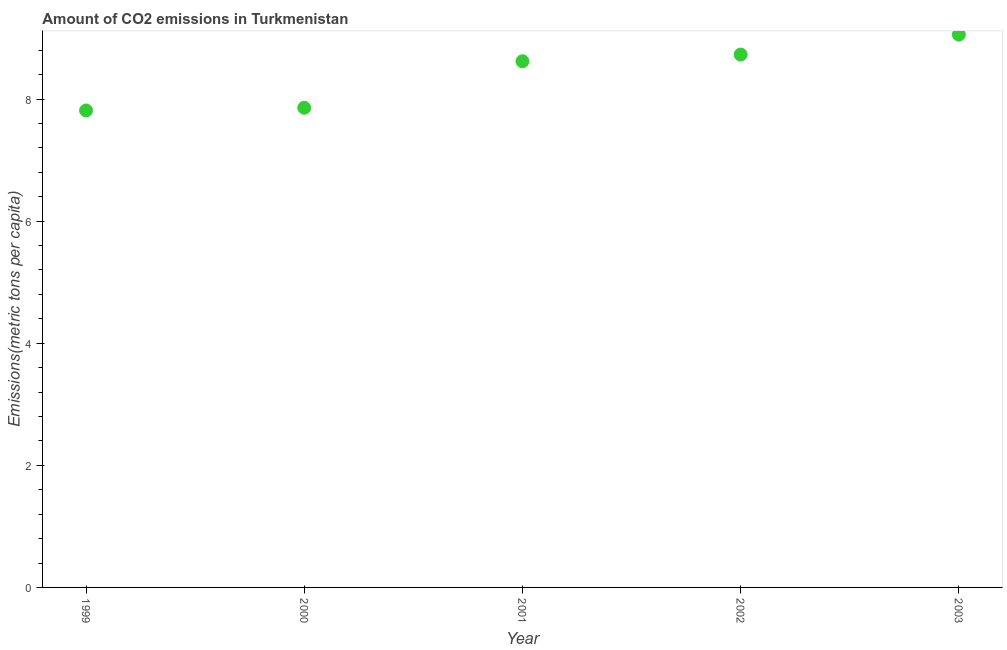What is the amount of co2 emissions in 2003?
Offer a terse response. 9.05. Across all years, what is the maximum amount of co2 emissions?
Provide a succinct answer. 9.05. Across all years, what is the minimum amount of co2 emissions?
Provide a short and direct response. 7.81. In which year was the amount of co2 emissions maximum?
Make the answer very short. 2003. In which year was the amount of co2 emissions minimum?
Offer a very short reply. 1999. What is the sum of the amount of co2 emissions?
Make the answer very short. 42.07. What is the difference between the amount of co2 emissions in 1999 and 2000?
Offer a terse response. -0.04. What is the average amount of co2 emissions per year?
Make the answer very short. 8.41. What is the median amount of co2 emissions?
Give a very brief answer. 8.62. What is the ratio of the amount of co2 emissions in 2002 to that in 2003?
Your answer should be compact. 0.96. Is the amount of co2 emissions in 2001 less than that in 2002?
Offer a terse response. Yes. What is the difference between the highest and the second highest amount of co2 emissions?
Your answer should be very brief. 0.33. Is the sum of the amount of co2 emissions in 2000 and 2002 greater than the maximum amount of co2 emissions across all years?
Your answer should be very brief. Yes. What is the difference between the highest and the lowest amount of co2 emissions?
Offer a terse response. 1.24. Does the amount of co2 emissions monotonically increase over the years?
Give a very brief answer. Yes. How many dotlines are there?
Provide a short and direct response. 1. How many years are there in the graph?
Keep it short and to the point. 5. What is the difference between two consecutive major ticks on the Y-axis?
Your answer should be very brief. 2. Does the graph contain any zero values?
Your answer should be very brief. No. What is the title of the graph?
Offer a very short reply. Amount of CO2 emissions in Turkmenistan. What is the label or title of the X-axis?
Ensure brevity in your answer.  Year. What is the label or title of the Y-axis?
Provide a short and direct response. Emissions(metric tons per capita). What is the Emissions(metric tons per capita) in 1999?
Your answer should be very brief. 7.81. What is the Emissions(metric tons per capita) in 2000?
Give a very brief answer. 7.86. What is the Emissions(metric tons per capita) in 2001?
Make the answer very short. 8.62. What is the Emissions(metric tons per capita) in 2002?
Your answer should be very brief. 8.73. What is the Emissions(metric tons per capita) in 2003?
Your response must be concise. 9.05. What is the difference between the Emissions(metric tons per capita) in 1999 and 2000?
Make the answer very short. -0.04. What is the difference between the Emissions(metric tons per capita) in 1999 and 2001?
Your response must be concise. -0.81. What is the difference between the Emissions(metric tons per capita) in 1999 and 2002?
Provide a succinct answer. -0.92. What is the difference between the Emissions(metric tons per capita) in 1999 and 2003?
Make the answer very short. -1.24. What is the difference between the Emissions(metric tons per capita) in 2000 and 2001?
Your answer should be compact. -0.76. What is the difference between the Emissions(metric tons per capita) in 2000 and 2002?
Make the answer very short. -0.87. What is the difference between the Emissions(metric tons per capita) in 2000 and 2003?
Make the answer very short. -1.2. What is the difference between the Emissions(metric tons per capita) in 2001 and 2002?
Offer a very short reply. -0.11. What is the difference between the Emissions(metric tons per capita) in 2001 and 2003?
Keep it short and to the point. -0.44. What is the difference between the Emissions(metric tons per capita) in 2002 and 2003?
Offer a very short reply. -0.33. What is the ratio of the Emissions(metric tons per capita) in 1999 to that in 2000?
Your answer should be very brief. 0.99. What is the ratio of the Emissions(metric tons per capita) in 1999 to that in 2001?
Keep it short and to the point. 0.91. What is the ratio of the Emissions(metric tons per capita) in 1999 to that in 2002?
Offer a very short reply. 0.9. What is the ratio of the Emissions(metric tons per capita) in 1999 to that in 2003?
Give a very brief answer. 0.86. What is the ratio of the Emissions(metric tons per capita) in 2000 to that in 2001?
Make the answer very short. 0.91. What is the ratio of the Emissions(metric tons per capita) in 2000 to that in 2003?
Your response must be concise. 0.87. What is the ratio of the Emissions(metric tons per capita) in 2002 to that in 2003?
Your response must be concise. 0.96. 